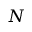Convert formula to latex. <formula><loc_0><loc_0><loc_500><loc_500>N</formula> 